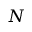Convert formula to latex. <formula><loc_0><loc_0><loc_500><loc_500>N</formula> 